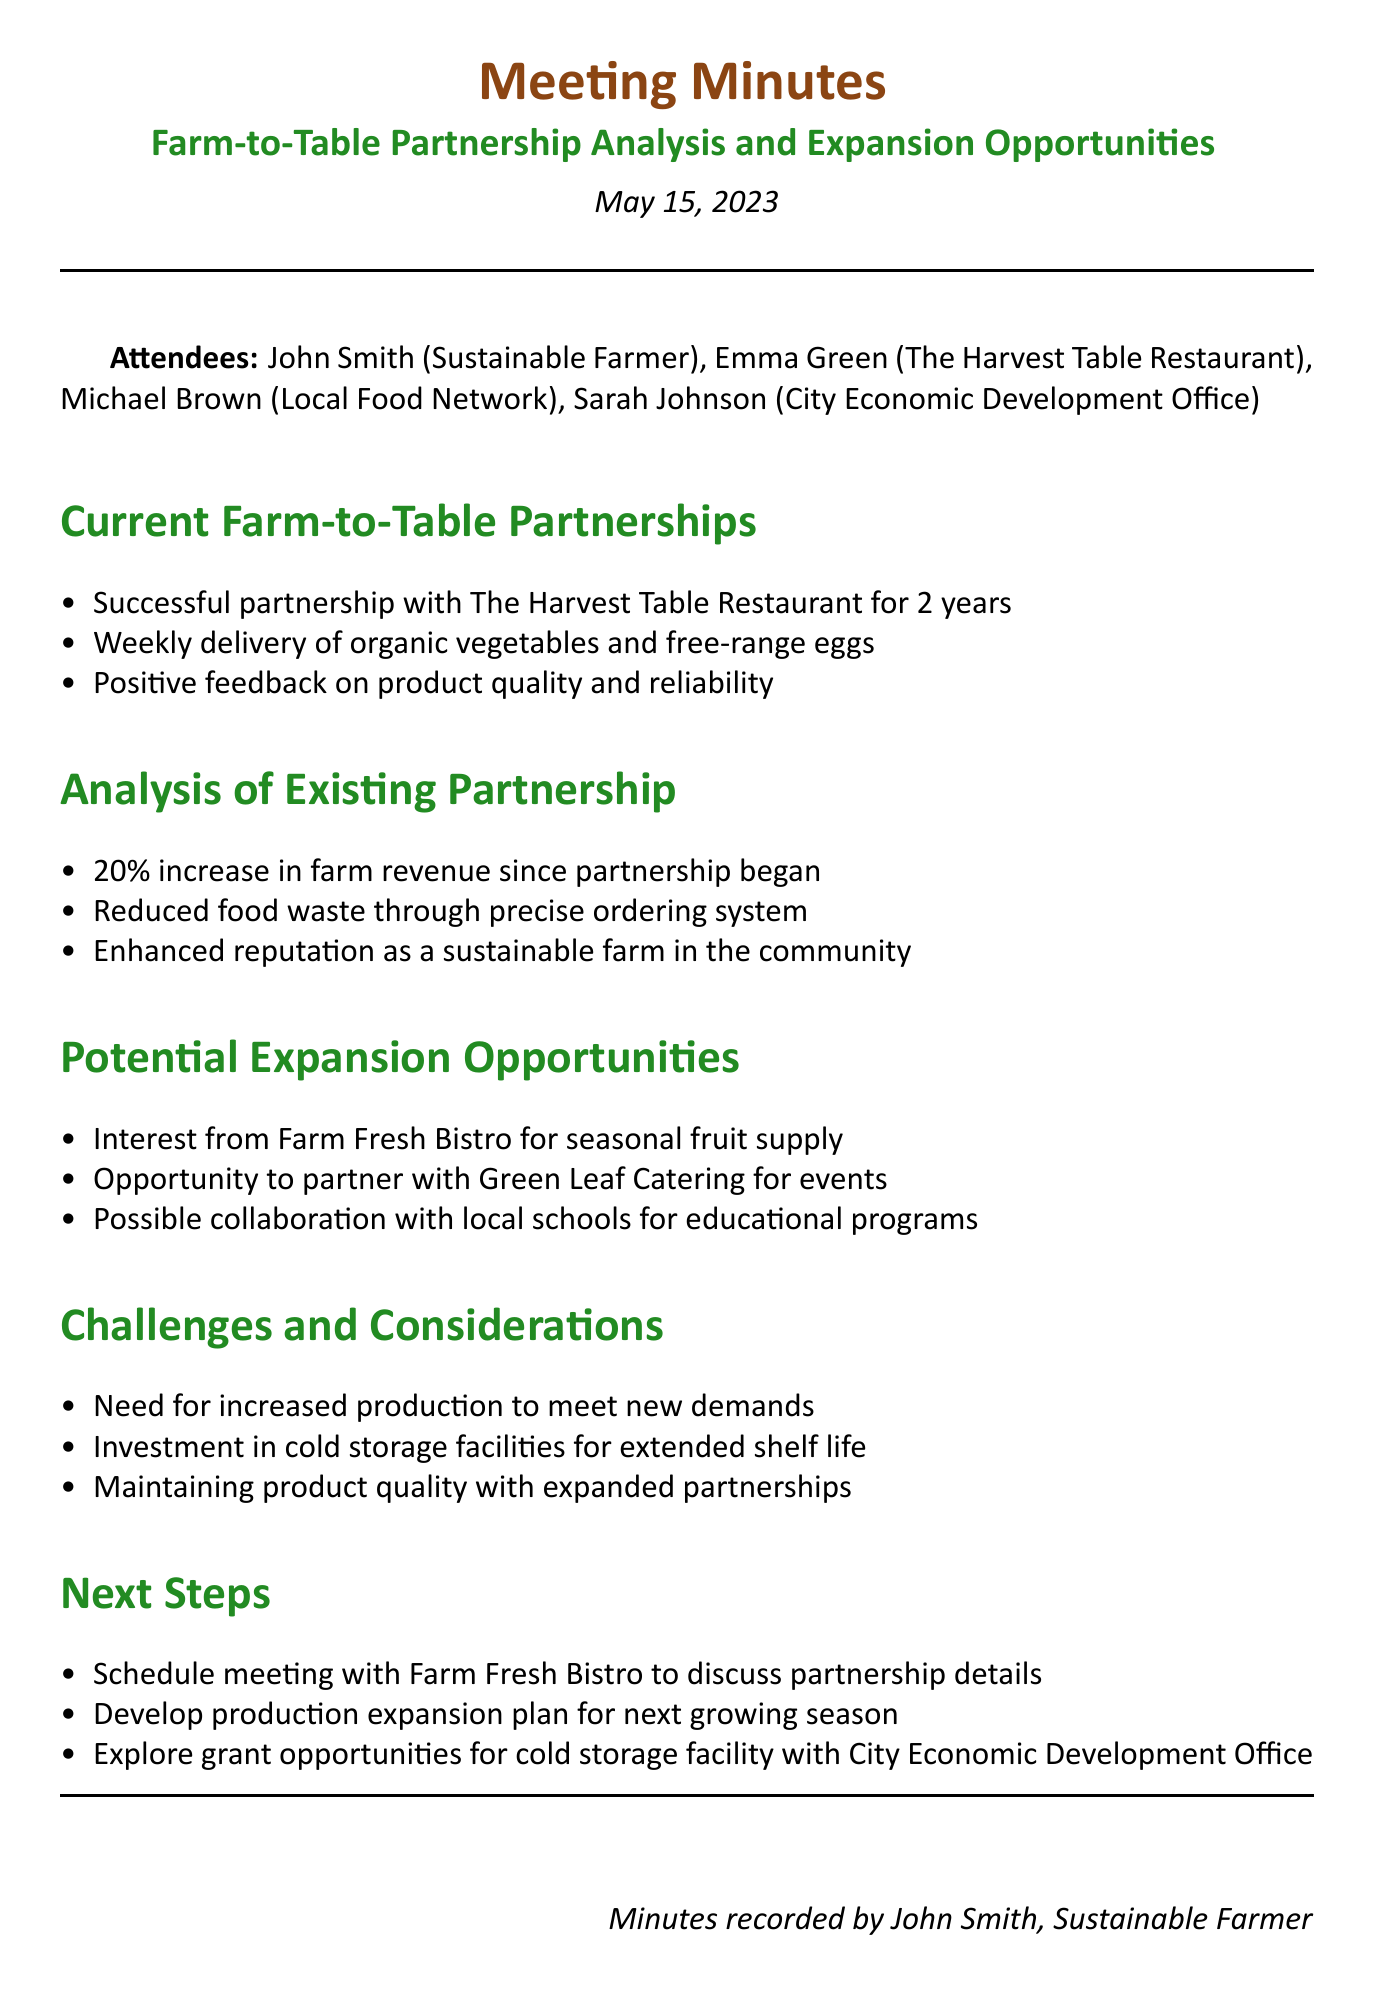What is the meeting title? The meeting title is specified at the beginning of the document and outlines the main subject of discussion.
Answer: Farm-to-Table Partnership Analysis and Expansion Opportunities Who is the representative from the City Economic Development Office? The document lists the attendees and identifies their roles during the meeting.
Answer: Sarah Johnson How many years has the partnership with The Harvest Table Restaurant been successful? The document indicates the duration of the partnership, highlighting its success.
Answer: 2 years What percentage increase in farm revenue has been realized since the partnership began? The document provides specific data on the financial impact of the partnership for clarity.
Answer: 20% Which restaurant expressed interest for a seasonal fruit supply? The document mentions potential partners and their areas of interest, capturing their interest clearly.
Answer: Farm Fresh Bistro What is one challenge mentioned in the meeting minutes? The minutes outline various challenges faced by the farm in expanding partnerships, indicating specific concerns.
Answer: Increased production What is one next step discussed in the meeting? The document includes actionable points to be taken after the discussion, indicating directions for future work.
Answer: Schedule meeting with Farm Fresh Bistro Which organization might provide grants for cold storage facilities? The document highlights relevant organizations involved in supporting the expansion of sustainable farming initiatives.
Answer: City Economic Development Office What type of products are delivered to The Harvest Table Restaurant? The document details the products supplied to the restaurant, emphasizing the types of produce involved in the partnership.
Answer: Organic vegetables and free-range eggs 